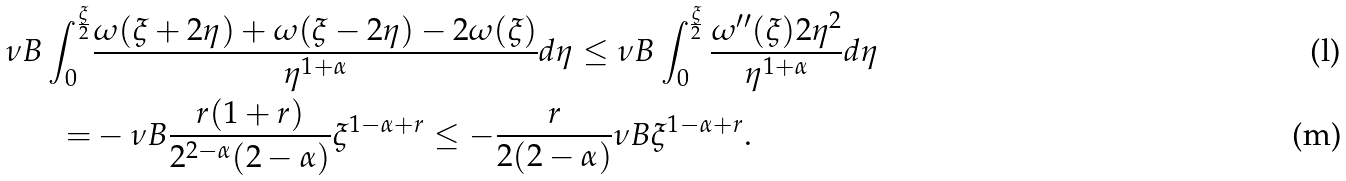<formula> <loc_0><loc_0><loc_500><loc_500>\nu B \int _ { 0 } ^ { \frac { \xi } { 2 } } & \frac { \omega ( \xi + 2 \eta ) + \omega ( \xi - 2 \eta ) - 2 \omega ( \xi ) } { \eta ^ { 1 + \alpha } } d \eta \leq \nu B \int _ { 0 } ^ { \frac { \xi } { 2 } } \frac { \omega ^ { \prime \prime } ( \xi ) 2 \eta ^ { 2 } } { \eta ^ { 1 + \alpha } } d \eta \\ = & - \nu B \frac { r ( 1 + r ) } { 2 ^ { 2 - \alpha } ( 2 - \alpha ) } \xi ^ { 1 - \alpha + r } \leq - \frac { r } { 2 ( 2 - \alpha ) } \nu B \xi ^ { 1 - \alpha + r } .</formula> 